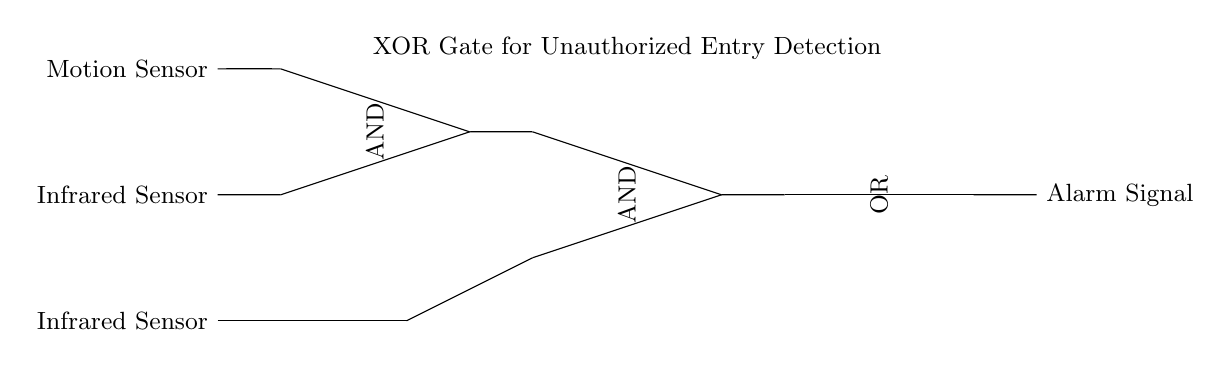What is the primary function of the XOR gate in this circuit? The XOR gate serves to detect unauthorized entry by comparing inputs from the motion sensor and infrared sensor. It outputs a signal only when one of the inputs is active, indicating a potential breach when the other sensor is inactive.
Answer: detect unauthorized entry What type of sensors are used as inputs to the AND gates? The sensors used as inputs are a motion sensor and an infrared sensor, which detect movement and heat signatures, respectively.
Answer: motion sensor and infrared sensor How many AND gates are present in the circuit? There are two AND gates in the circuit. One receives the direct signals from the motion and infrared sensors, while the other is used after the NOT gate for the infrared sensor signal.
Answer: two What is the output of the OR gate? The output of the OR gate is an alarm signal, which indicates whether the conditions for unauthorized entry are met based on the input from the AND gates.
Answer: alarm signal When will the alarm signal be activated? The alarm signal will be activated when either the motion sensor detects movement or the infrared sensor detects an intruder, while the other sensor is not active (the XOR condition).
Answer: when either sensor detects a breach What type of logic does the circuit's XOR gate implement? The XOR gate implements exclusive logic, meaning it will produce a true output only when its inputs differ; that is, when one is true (active) and the other is false (inactive).
Answer: exclusive logic 